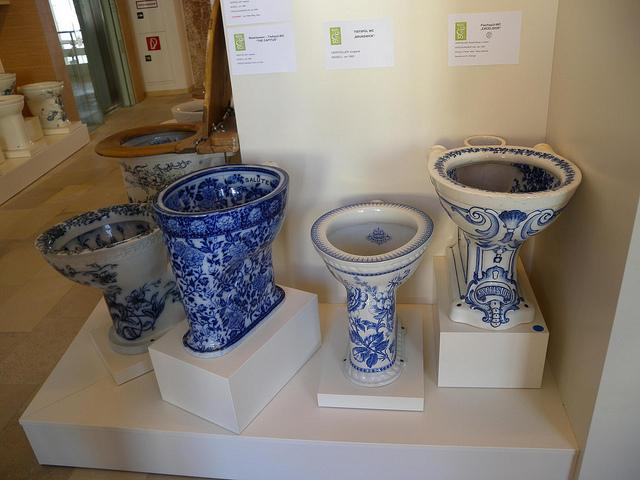Where would this style of porcelain item be found in a house? bathroom 